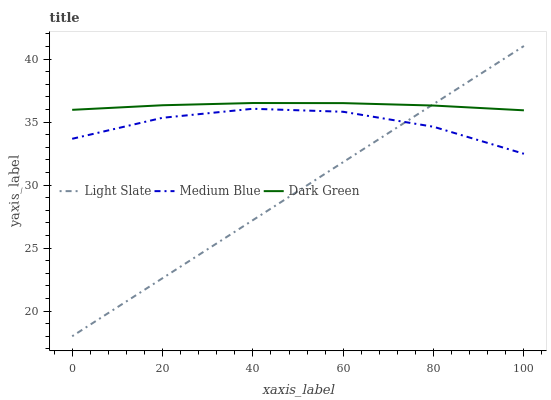Does Light Slate have the minimum area under the curve?
Answer yes or no. Yes. Does Dark Green have the maximum area under the curve?
Answer yes or no. Yes. Does Medium Blue have the minimum area under the curve?
Answer yes or no. No. Does Medium Blue have the maximum area under the curve?
Answer yes or no. No. Is Light Slate the smoothest?
Answer yes or no. Yes. Is Medium Blue the roughest?
Answer yes or no. Yes. Is Dark Green the smoothest?
Answer yes or no. No. Is Dark Green the roughest?
Answer yes or no. No. Does Light Slate have the lowest value?
Answer yes or no. Yes. Does Medium Blue have the lowest value?
Answer yes or no. No. Does Light Slate have the highest value?
Answer yes or no. Yes. Does Dark Green have the highest value?
Answer yes or no. No. Is Medium Blue less than Dark Green?
Answer yes or no. Yes. Is Dark Green greater than Medium Blue?
Answer yes or no. Yes. Does Light Slate intersect Medium Blue?
Answer yes or no. Yes. Is Light Slate less than Medium Blue?
Answer yes or no. No. Is Light Slate greater than Medium Blue?
Answer yes or no. No. Does Medium Blue intersect Dark Green?
Answer yes or no. No. 